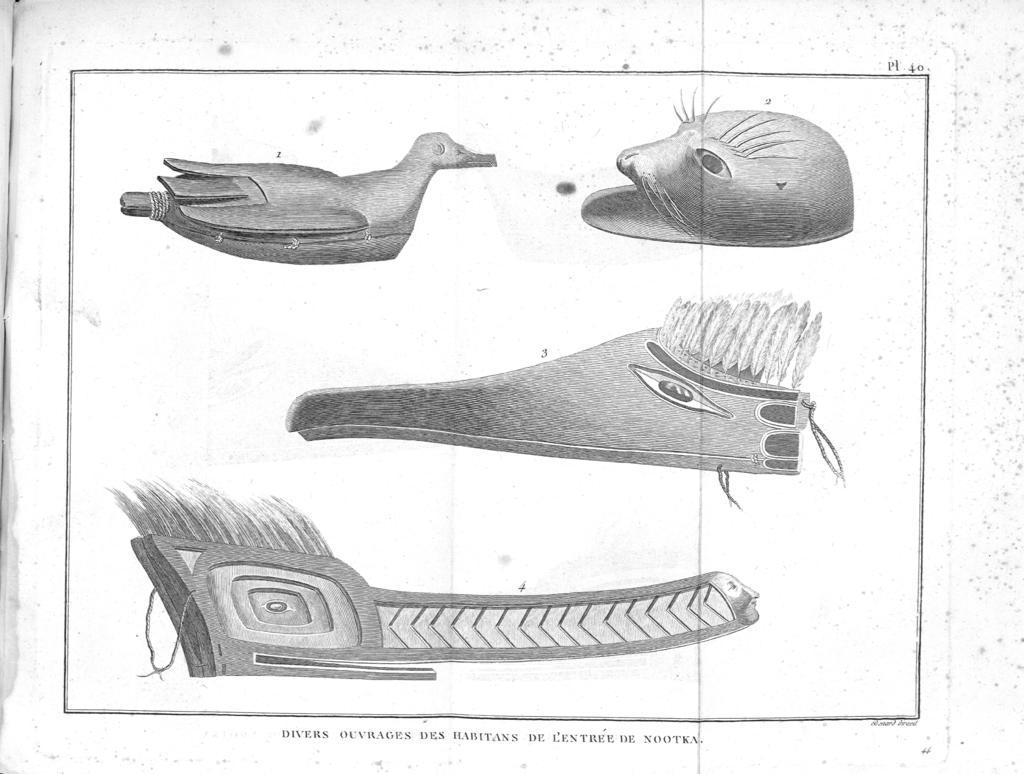What type of artwork is depicted in the image? The image is a painting. What can be seen in the middle of the painting? There are pictures drawn on a white color paper in the middle of the image. Is there any text present in the image? Yes, there is text at the bottom of the image. What type of horn can be seen in the image? There is no horn present in the image. What is the front of the image made of? The front of the image refers to the visible part of the painting, which is made of the painting material itself, not a specific material. 